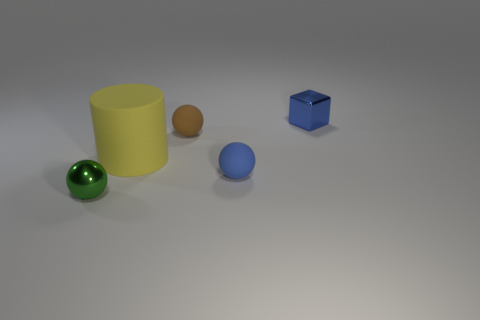Is there any other thing that has the same size as the yellow matte cylinder?
Keep it short and to the point. No. The big object that is the same material as the tiny brown thing is what shape?
Give a very brief answer. Cylinder. How big is the shiny thing right of the tiny metal object that is on the left side of the small blue shiny block?
Offer a terse response. Small. What color is the metallic block that is behind the yellow rubber cylinder?
Make the answer very short. Blue. Is there another gray metal thing of the same shape as the large object?
Provide a short and direct response. No. Is the number of small shiny things on the right side of the tiny green metallic ball less than the number of blue things on the right side of the tiny block?
Provide a succinct answer. No. The shiny cube has what color?
Your answer should be very brief. Blue. Are there any rubber cylinders right of the blue object in front of the yellow cylinder?
Your answer should be very brief. No. How many green shiny spheres are the same size as the blue cube?
Provide a succinct answer. 1. What number of tiny brown balls are right of the small shiny object to the right of the small shiny thing that is in front of the cube?
Your answer should be very brief. 0. 